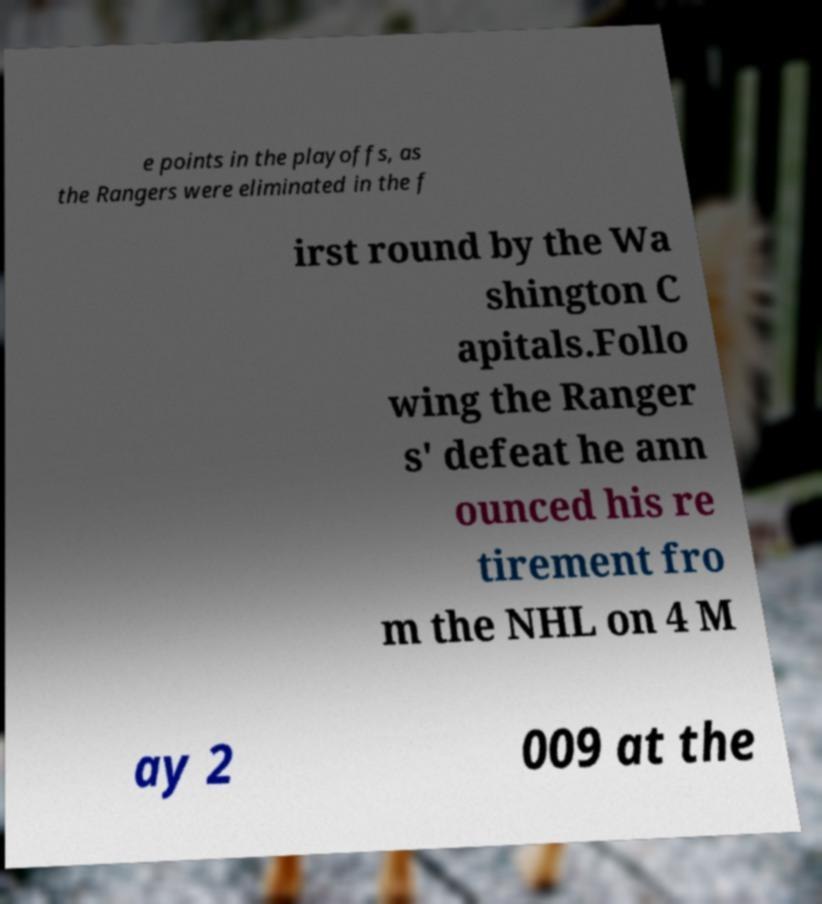For documentation purposes, I need the text within this image transcribed. Could you provide that? e points in the playoffs, as the Rangers were eliminated in the f irst round by the Wa shington C apitals.Follo wing the Ranger s' defeat he ann ounced his re tirement fro m the NHL on 4 M ay 2 009 at the 